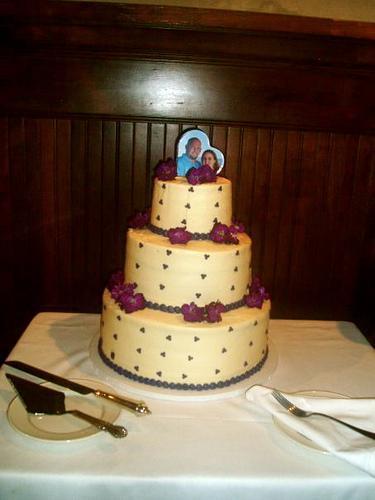How many tiers does this cake have?
Give a very brief answer. 3. How many people are in this photo?
Give a very brief answer. 0. How many cakes can you see?
Give a very brief answer. 1. How many stacks of bowls are there?
Give a very brief answer. 0. 